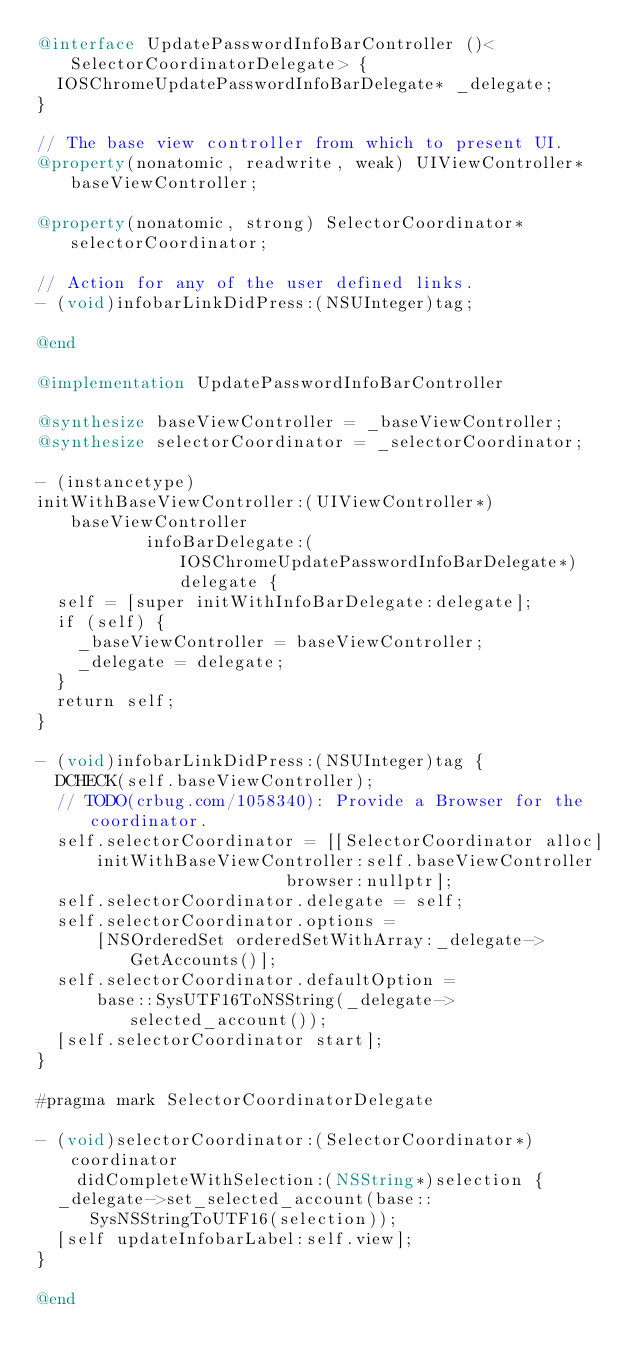<code> <loc_0><loc_0><loc_500><loc_500><_ObjectiveC_>@interface UpdatePasswordInfoBarController ()<SelectorCoordinatorDelegate> {
  IOSChromeUpdatePasswordInfoBarDelegate* _delegate;
}

// The base view controller from which to present UI.
@property(nonatomic, readwrite, weak) UIViewController* baseViewController;

@property(nonatomic, strong) SelectorCoordinator* selectorCoordinator;

// Action for any of the user defined links.
- (void)infobarLinkDidPress:(NSUInteger)tag;

@end

@implementation UpdatePasswordInfoBarController

@synthesize baseViewController = _baseViewController;
@synthesize selectorCoordinator = _selectorCoordinator;

- (instancetype)
initWithBaseViewController:(UIViewController*)baseViewController
           infoBarDelegate:(IOSChromeUpdatePasswordInfoBarDelegate*)delegate {
  self = [super initWithInfoBarDelegate:delegate];
  if (self) {
    _baseViewController = baseViewController;
    _delegate = delegate;
  }
  return self;
}

- (void)infobarLinkDidPress:(NSUInteger)tag {
  DCHECK(self.baseViewController);
  // TODO(crbug.com/1058340): Provide a Browser for the coordinator.
  self.selectorCoordinator = [[SelectorCoordinator alloc]
      initWithBaseViewController:self.baseViewController
                         browser:nullptr];
  self.selectorCoordinator.delegate = self;
  self.selectorCoordinator.options =
      [NSOrderedSet orderedSetWithArray:_delegate->GetAccounts()];
  self.selectorCoordinator.defaultOption =
      base::SysUTF16ToNSString(_delegate->selected_account());
  [self.selectorCoordinator start];
}

#pragma mark SelectorCoordinatorDelegate

- (void)selectorCoordinator:(SelectorCoordinator*)coordinator
    didCompleteWithSelection:(NSString*)selection {
  _delegate->set_selected_account(base::SysNSStringToUTF16(selection));
  [self updateInfobarLabel:self.view];
}

@end
</code> 